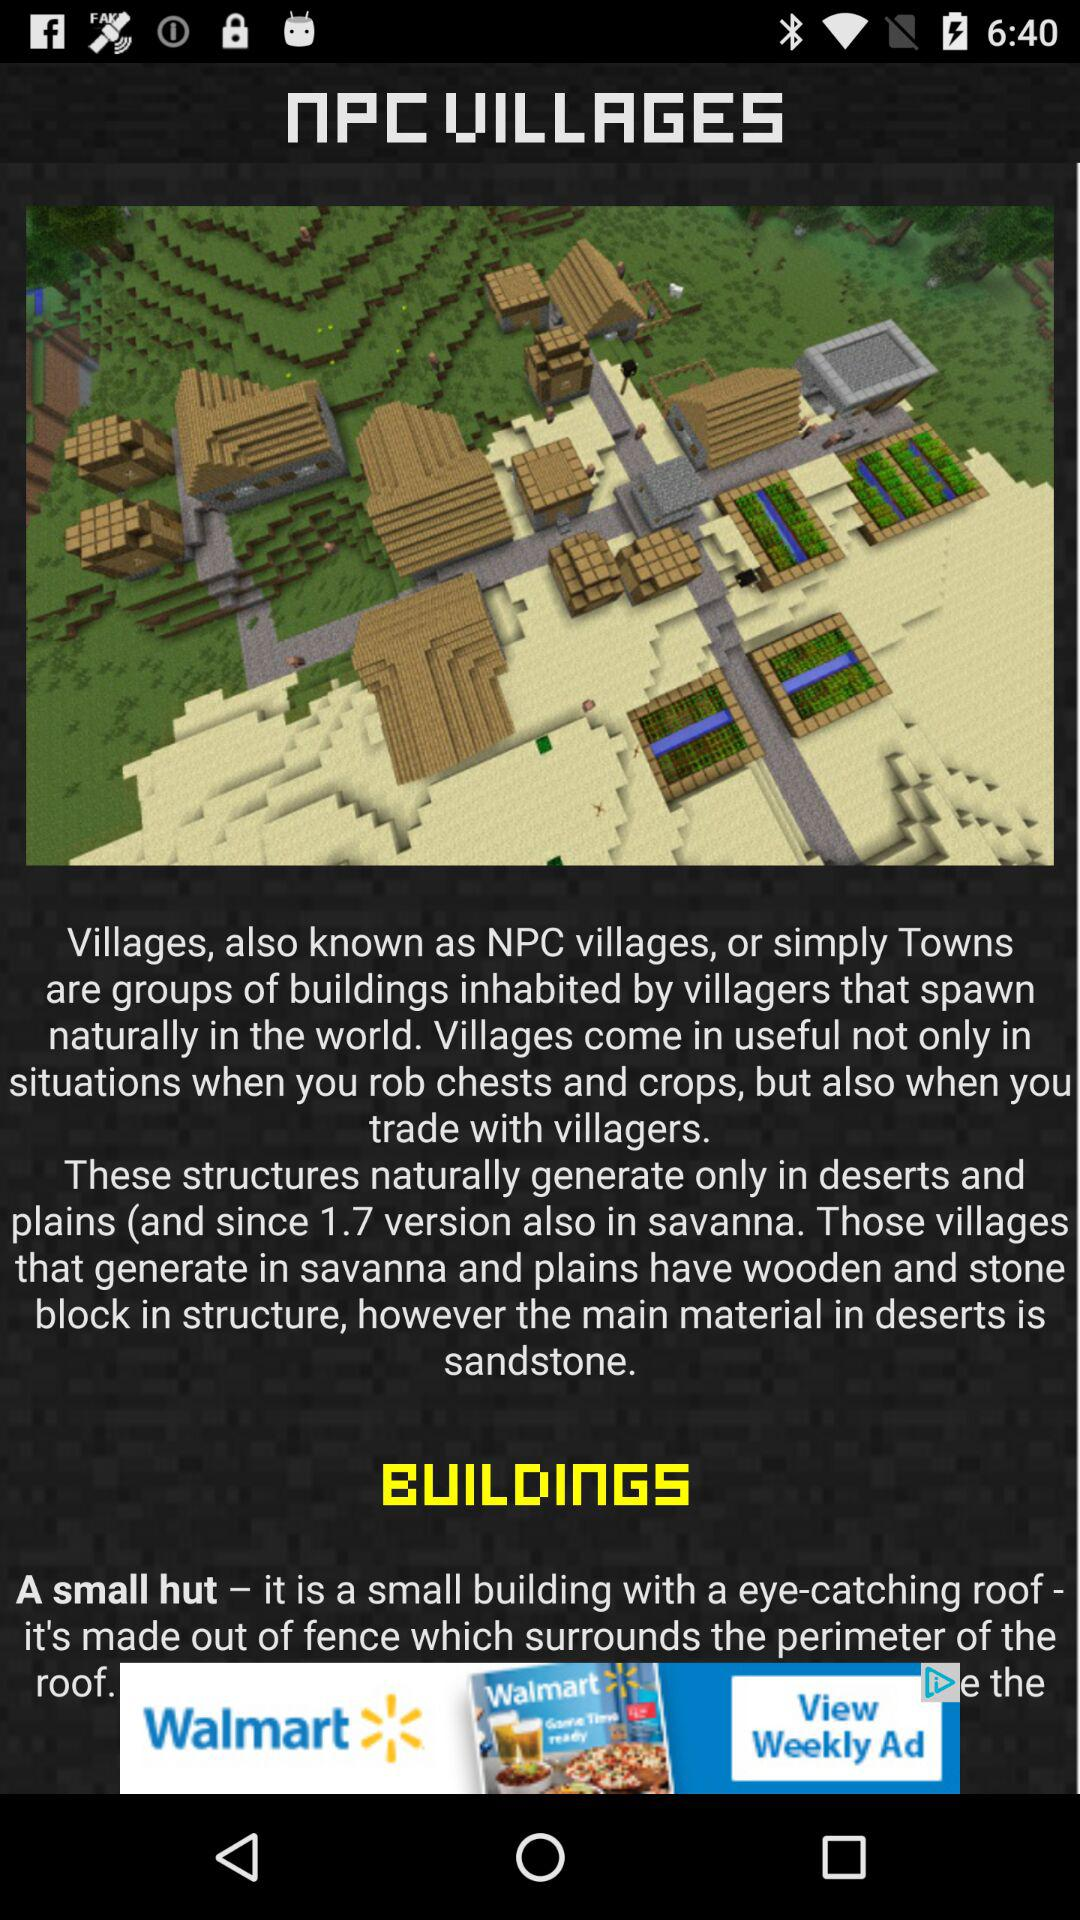What is the main material in deserts? The main material in deserts is sandstone. 